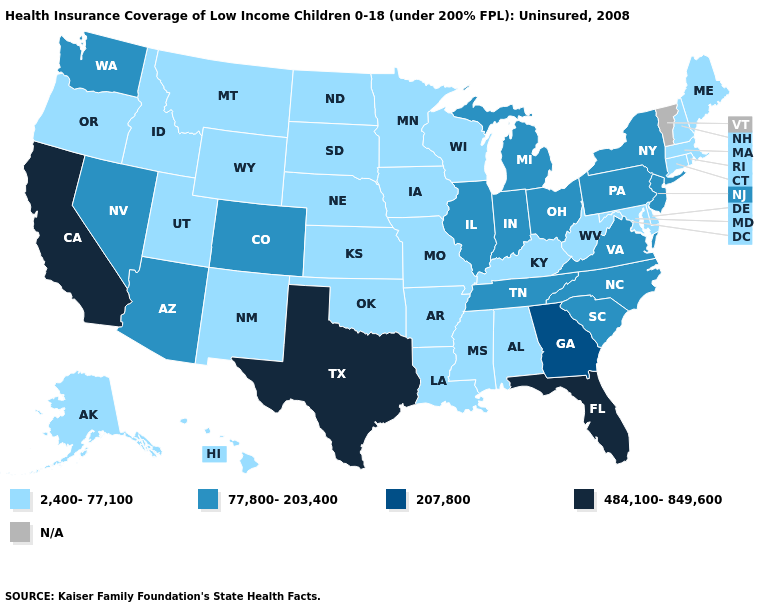What is the lowest value in states that border New Mexico?
Keep it brief. 2,400-77,100. Which states have the highest value in the USA?
Be succinct. California, Florida, Texas. What is the lowest value in states that border New Hampshire?
Answer briefly. 2,400-77,100. What is the highest value in the USA?
Keep it brief. 484,100-849,600. Does Missouri have the highest value in the USA?
Keep it brief. No. What is the value of Indiana?
Keep it brief. 77,800-203,400. Name the states that have a value in the range N/A?
Answer briefly. Vermont. What is the lowest value in the South?
Quick response, please. 2,400-77,100. What is the value of Alabama?
Keep it brief. 2,400-77,100. What is the value of Utah?
Keep it brief. 2,400-77,100. Does Ohio have the lowest value in the USA?
Answer briefly. No. Among the states that border California , does Oregon have the lowest value?
Keep it brief. Yes. What is the lowest value in the South?
Keep it brief. 2,400-77,100. Which states have the highest value in the USA?
Concise answer only. California, Florida, Texas. 